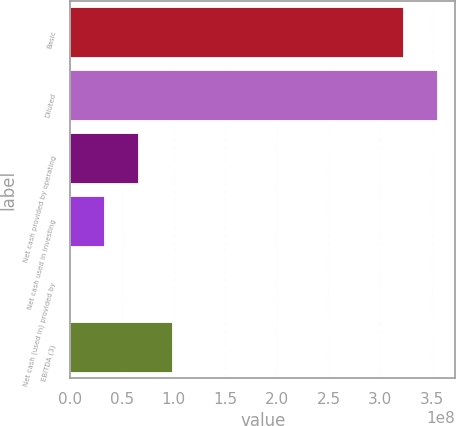<chart> <loc_0><loc_0><loc_500><loc_500><bar_chart><fcel>Basic<fcel>Diluted<fcel>Net cash provided by operating<fcel>Net cash used in investing<fcel>Net cash (used in) provided by<fcel>EBITDA (3)<nl><fcel>3.22316e+08<fcel>3.5501e+08<fcel>6.54894e+07<fcel>3.2795e+07<fcel>100689<fcel>9.81837e+07<nl></chart> 